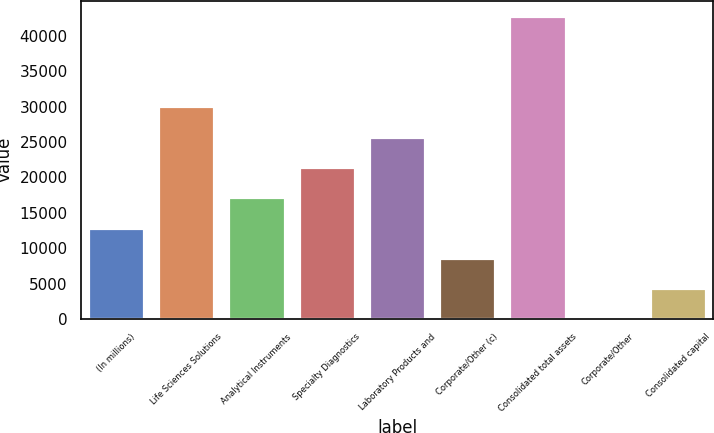<chart> <loc_0><loc_0><loc_500><loc_500><bar_chart><fcel>(In millions)<fcel>Life Sciences Solutions<fcel>Analytical Instruments<fcel>Specialty Diagnostics<fcel>Laboratory Products and<fcel>Corporate/Other (c)<fcel>Consolidated total assets<fcel>Corporate/Other<fcel>Consolidated capital<nl><fcel>12924.4<fcel>30026<fcel>17199.8<fcel>21475.2<fcel>25750.6<fcel>8649.06<fcel>42852.1<fcel>98.3<fcel>4373.68<nl></chart> 